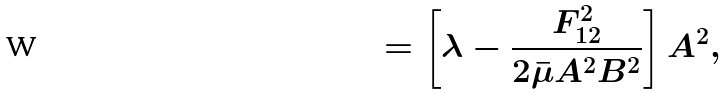Convert formula to latex. <formula><loc_0><loc_0><loc_500><loc_500>= \left [ \lambda - \frac { F ^ { 2 } _ { 1 2 } } { 2 \bar { \mu } A ^ { 2 } B ^ { 2 } } \right ] A ^ { 2 } ,</formula> 